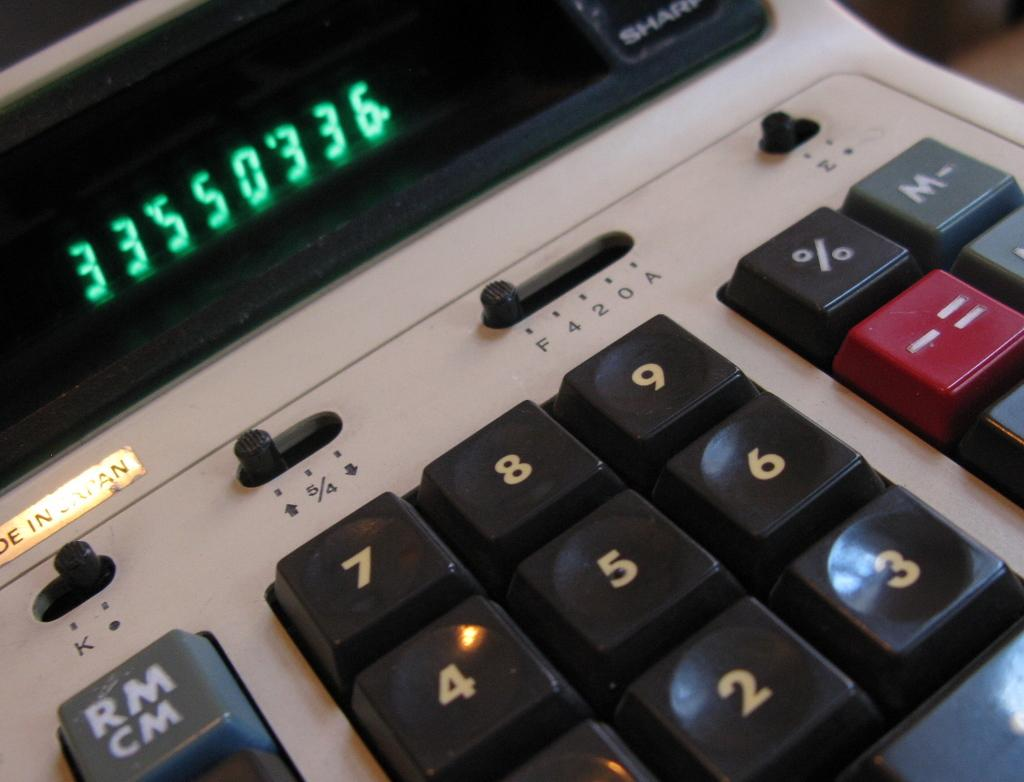Provide a one-sentence caption for the provided image. a digital screen that has the numbers 33550336. 